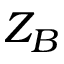<formula> <loc_0><loc_0><loc_500><loc_500>Z _ { B }</formula> 